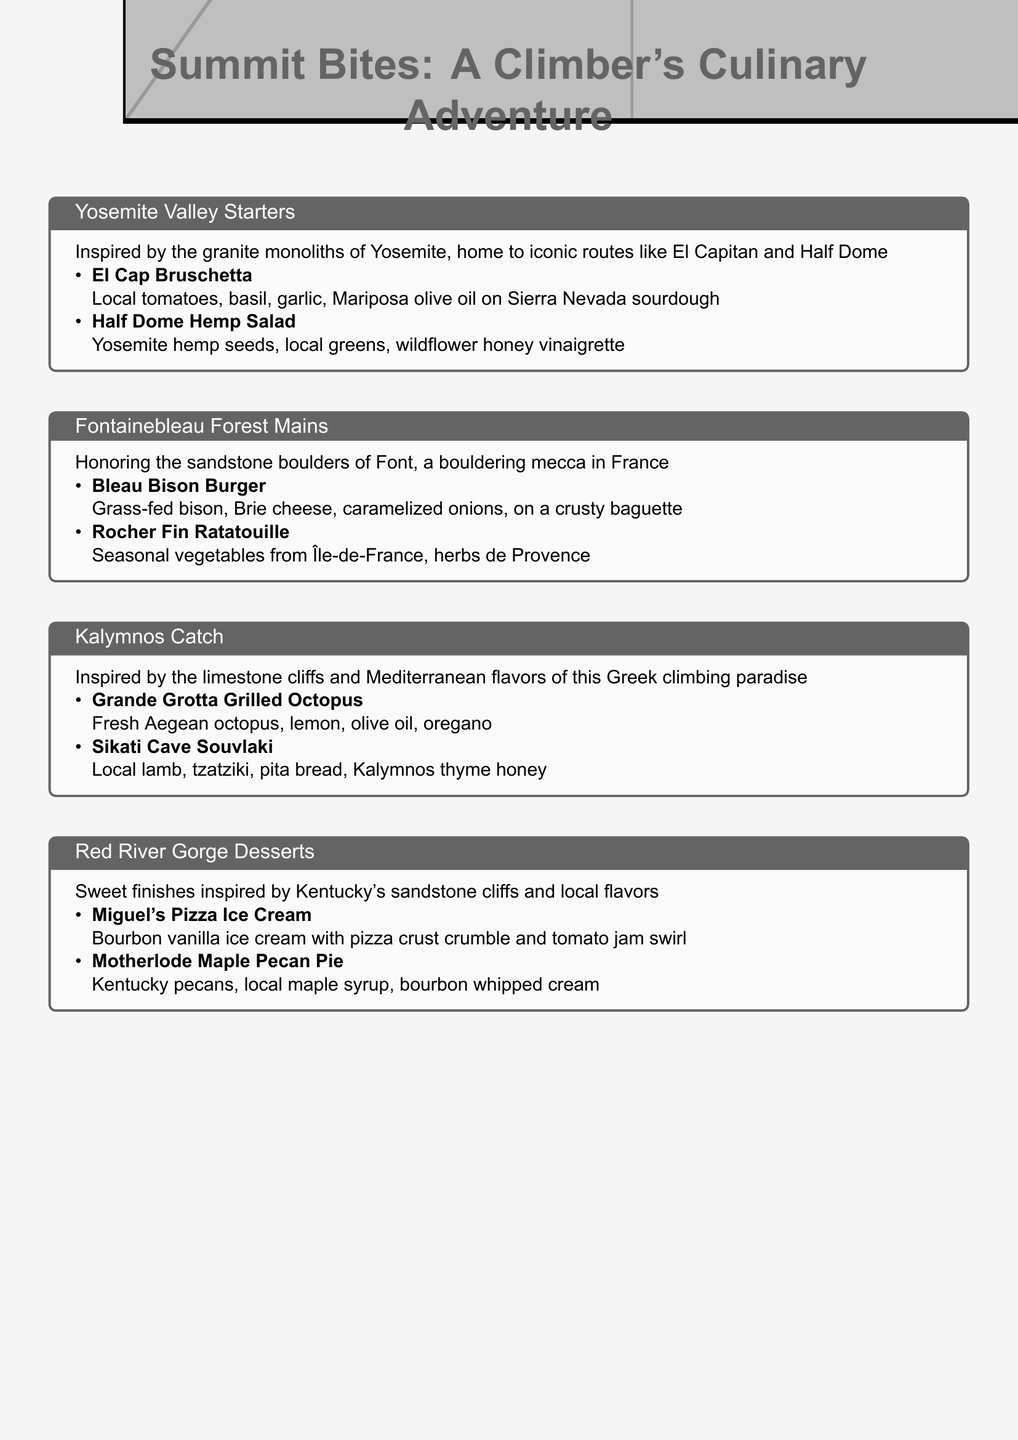What is the name of the salad inspired by Yosemite? The salad inspired by Yosemite is called Half Dome Hemp Salad.
Answer: Half Dome Hemp Salad What ingredients are in the Bleau Bison Burger? The Bleau Bison Burger is made with grass-fed bison, Brie cheese, and caramelized onions.
Answer: Grass-fed bison, Brie cheese, caramelized onions What climbing destination is known for its limestone cliffs? The climbing destination known for its limestone cliffs is Kalymnos.
Answer: Kalymnos Which dessert features local maple syrup? The dessert featuring local maple syrup is Motherlode Maple Pecan Pie.
Answer: Motherlode Maple Pecan Pie What type of cuisine is represented in the Fontainebleau Forest mains? The cuisine represented in the Fontainebleau Forest mains is French.
Answer: French How many starters are featured from Yosemite Valley? There are two starters featured from Yosemite Valley.
Answer: Two What is the main protein in Sikati Cave Souvlaki? The main protein in Sikati Cave Souvlaki is lamb.
Answer: Lamb What is the highlight of the Red River Gorge desserts? The highlight of the Red River Gorge desserts is local flavors.
Answer: Local flavors 